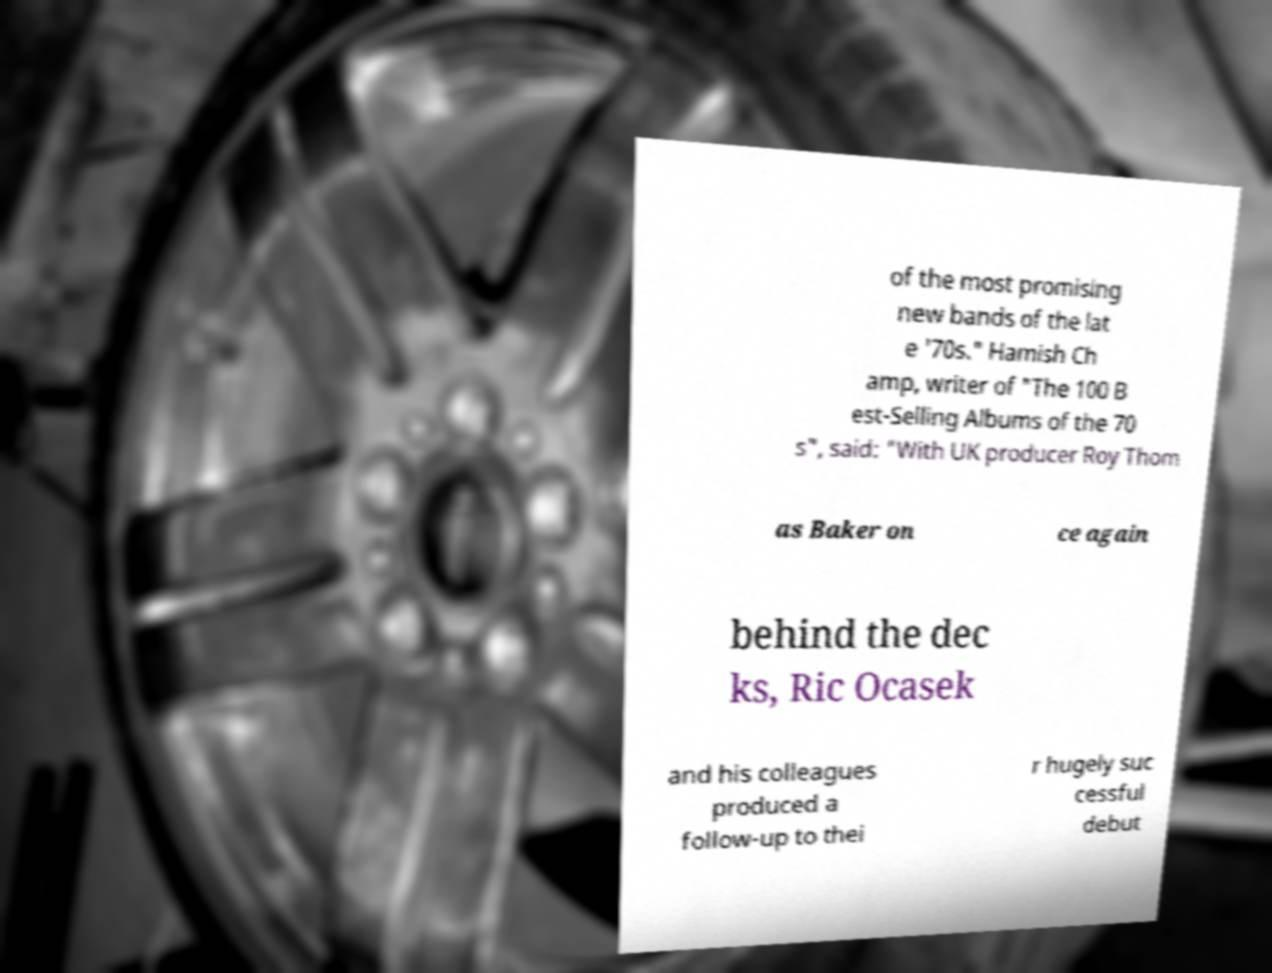There's text embedded in this image that I need extracted. Can you transcribe it verbatim? of the most promising new bands of the lat e '70s." Hamish Ch amp, writer of "The 100 B est-Selling Albums of the 70 s", said: "With UK producer Roy Thom as Baker on ce again behind the dec ks, Ric Ocasek and his colleagues produced a follow-up to thei r hugely suc cessful debut 